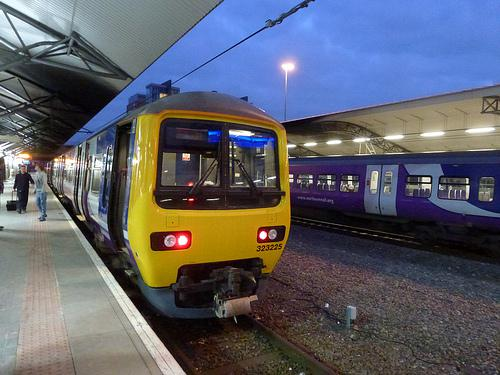Question: how many people are in the picture?
Choices:
A. Two.
B. Three.
C. Five.
D. Six.
Answer with the letter. Answer: A Question: when was the picture taken?
Choices:
A. At breakfast.
B. At night.
C. In the afternoon.
D. Before dinner.
Answer with the letter. Answer: B Question: what is the man pulling?
Choices:
A. Mower.
B. Luggage.
C. Wagon.
D. Sled.
Answer with the letter. Answer: B Question: where was the picture taken?
Choices:
A. A train station.
B. A farm.
C. A hill.
D. A backyard.
Answer with the letter. Answer: A Question: what color is the sky?
Choices:
A. Blue.
B. Gray.
C. Orange.
D. White.
Answer with the letter. Answer: A Question: who is standing in the picture?
Choices:
A. A boy.
B. A man and a boy.
C. Two men.
D. A woman and a man.
Answer with the letter. Answer: C 